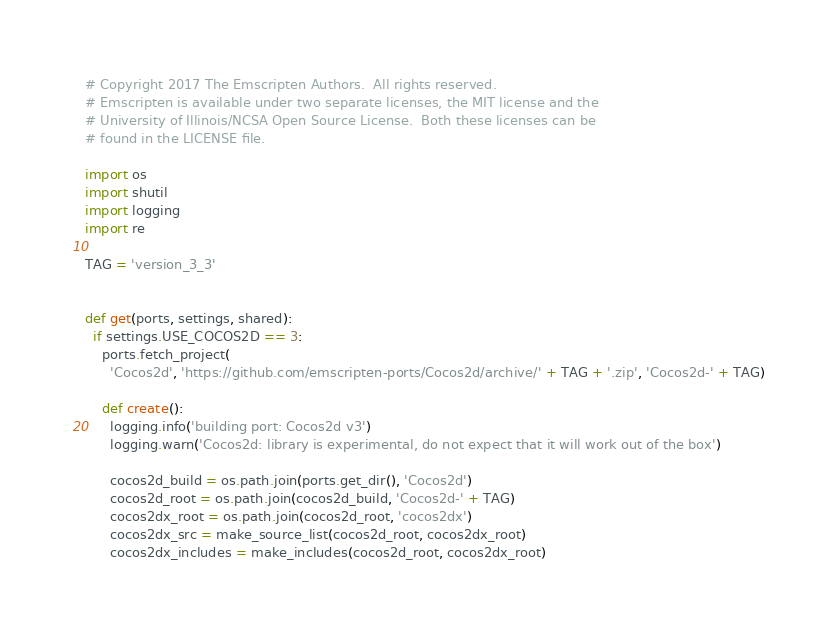Convert code to text. <code><loc_0><loc_0><loc_500><loc_500><_Python_># Copyright 2017 The Emscripten Authors.  All rights reserved.
# Emscripten is available under two separate licenses, the MIT license and the
# University of Illinois/NCSA Open Source License.  Both these licenses can be
# found in the LICENSE file.

import os
import shutil
import logging
import re

TAG = 'version_3_3'


def get(ports, settings, shared):
  if settings.USE_COCOS2D == 3:
    ports.fetch_project(
      'Cocos2d', 'https://github.com/emscripten-ports/Cocos2d/archive/' + TAG + '.zip', 'Cocos2d-' + TAG)

    def create():
      logging.info('building port: Cocos2d v3')
      logging.warn('Cocos2d: library is experimental, do not expect that it will work out of the box')

      cocos2d_build = os.path.join(ports.get_dir(), 'Cocos2d')
      cocos2d_root = os.path.join(cocos2d_build, 'Cocos2d-' + TAG)
      cocos2dx_root = os.path.join(cocos2d_root, 'cocos2dx')
      cocos2dx_src = make_source_list(cocos2d_root, cocos2dx_root)
      cocos2dx_includes = make_includes(cocos2d_root, cocos2dx_root)
</code> 